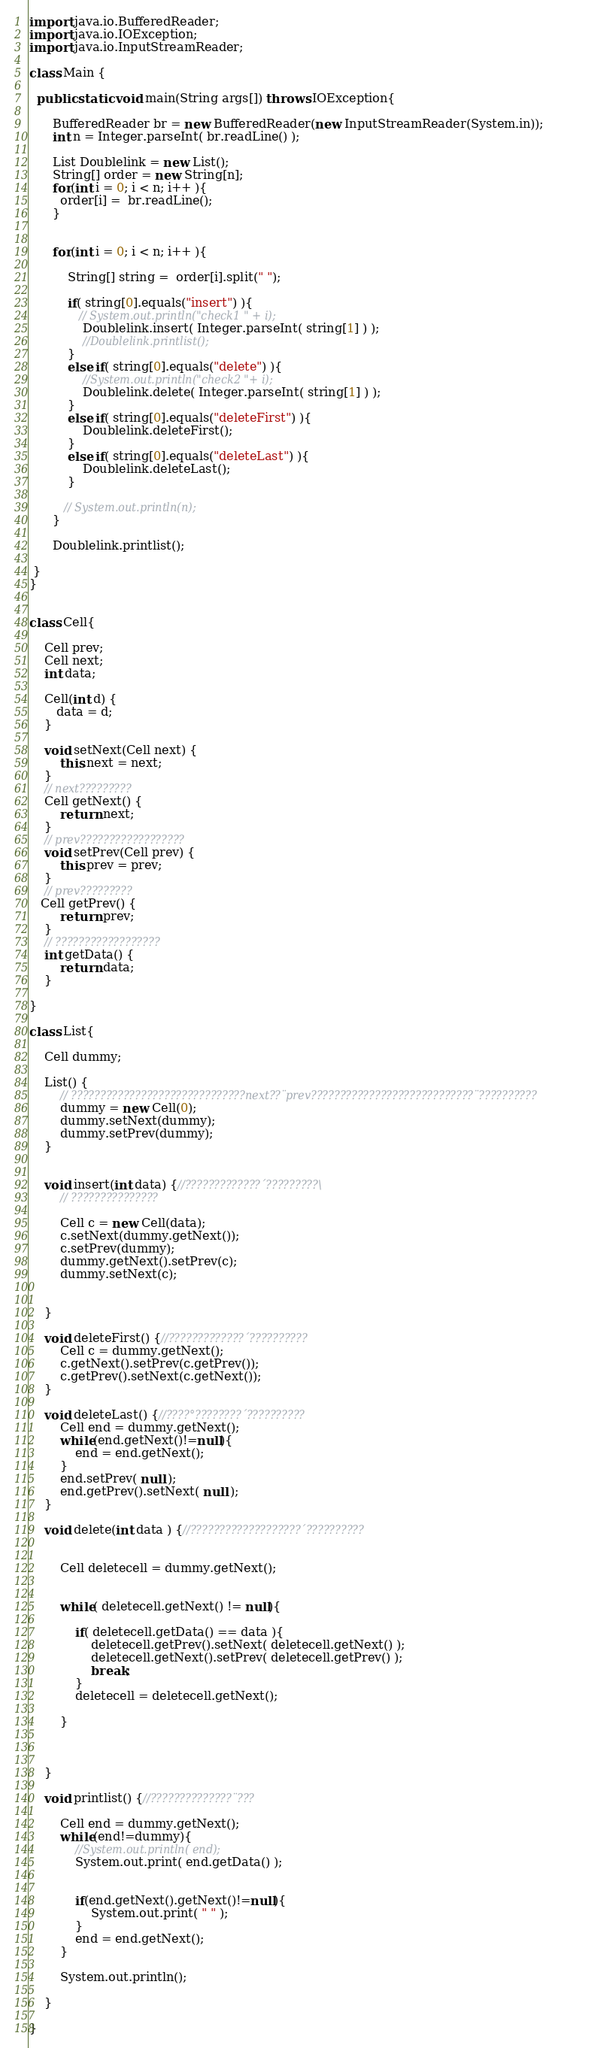<code> <loc_0><loc_0><loc_500><loc_500><_Java_>

import java.io.BufferedReader;
import java.io.IOException;
import java.io.InputStreamReader;

class Main {

  public static void main(String args[]) throws IOException{

	  BufferedReader br = new BufferedReader(new InputStreamReader(System.in));
      int n = Integer.parseInt( br.readLine() );

      List Doublelink = new List();
      String[] order = new String[n];
      for(int i = 0; i < n; i++ ){
        order[i] =  br.readLine();
      }


      for(int i = 0; i < n; i++ ){

    	  String[] string =  order[i].split(" ");

    	  if( string[0].equals("insert") ){
    		 // System.out.println("check1 " + i);
    		  Doublelink.insert( Integer.parseInt( string[1] ) );
    		  //Doublelink.printlist();
    	  }
    	  else if( string[0].equals("delete") ){
    		  //System.out.println("check2 "+ i);
    		  Doublelink.delete( Integer.parseInt( string[1] ) );
    	  }
    	  else if( string[0].equals("deleteFirst") ){
    		  Doublelink.deleteFirst();
    	  }
    	  else if( string[0].equals("deleteLast") ){
    		  Doublelink.deleteLast();
    	  }

    	 // System.out.println(n);
      }

      Doublelink.printlist();

 }
}


class Cell{

	Cell prev;
	Cell next;
	int data;

	Cell(int d) {
	   data = d;
	}

	void setNext(Cell next) {
        this.next = next;
    }
    // next?????????
    Cell getNext() {
        return next;
    }
    // prev??????????????????
    void setPrev(Cell prev) {
        this.prev = prev;
    }
    // prev?????????
   Cell getPrev() {
        return prev;
    }
    // ??????????????????
    int getData() {
        return data;
    }

}

class List{

    Cell dummy;

	List() {
        // ??????????????????????????????next??¨prev????????????????????????????¨??????????
        dummy = new Cell(0);
        dummy.setNext(dummy);
        dummy.setPrev(dummy);
    }


	void insert(int data) {//?????????????´?????????\
        // ???????????????

        Cell c = new Cell(data);
        c.setNext(dummy.getNext());
        c.setPrev(dummy);
        dummy.getNext().setPrev(c);
        dummy.setNext(c);


    }

	void deleteFirst() {//?????????????´??????????
        Cell c = dummy.getNext();
        c.getNext().setPrev(c.getPrev());
        c.getPrev().setNext(c.getNext());
    }

	void deleteLast() {//????°????????´??????????
		Cell end = dummy.getNext();
        while(end.getNext()!=null){
        	end = end.getNext();
        }
        end.setPrev( null );
        end.getPrev().setNext( null );
    }

	void delete(int data ) {//???????????????????´??????????


		Cell deletecell = dummy.getNext();


        while( deletecell.getNext() != null){

        	if( deletecell.getData() == data ){
        		deletecell.getPrev().setNext( deletecell.getNext() );
                deletecell.getNext().setPrev( deletecell.getPrev() );
                break;
        	}
        	deletecell = deletecell.getNext();

        }



	}

	void printlist() {//??????????????¨???

		Cell end = dummy.getNext();
        while(end!=dummy){
        	//System.out.println( end);
        	System.out.print( end.getData() );


        	if(end.getNext().getNext()!=null){
            	System.out.print( " " );
            }
        	end = end.getNext();
        }

        System.out.println();

	}

}</code> 